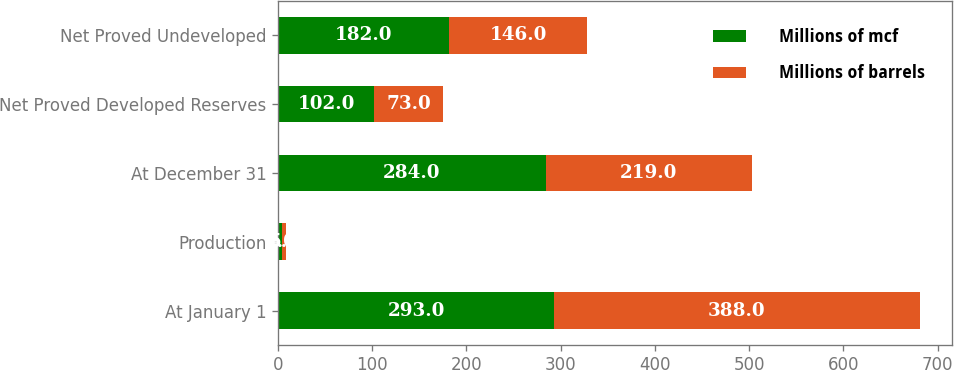Convert chart. <chart><loc_0><loc_0><loc_500><loc_500><stacked_bar_chart><ecel><fcel>At January 1<fcel>Production<fcel>At December 31<fcel>Net Proved Developed Reserves<fcel>Net Proved Undeveloped<nl><fcel>Millions of mcf<fcel>293<fcel>4<fcel>284<fcel>102<fcel>182<nl><fcel>Millions of barrels<fcel>388<fcel>5<fcel>219<fcel>73<fcel>146<nl></chart> 